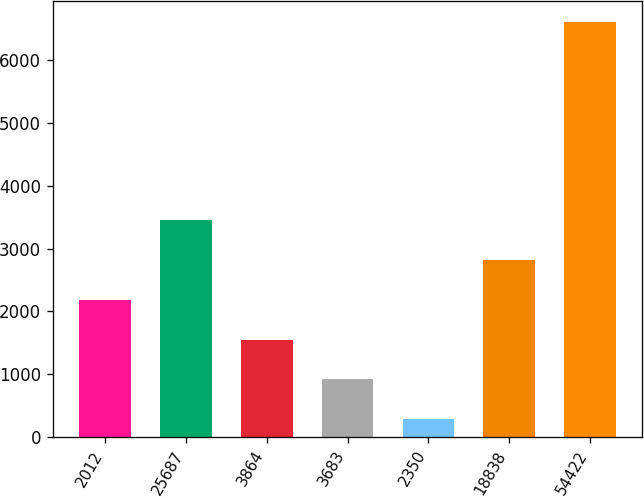Convert chart to OTSL. <chart><loc_0><loc_0><loc_500><loc_500><bar_chart><fcel>2012<fcel>25687<fcel>3864<fcel>3683<fcel>2350<fcel>18838<fcel>54422<nl><fcel>2181.3<fcel>3448.3<fcel>1547.8<fcel>914.3<fcel>280.8<fcel>2814.8<fcel>6615.8<nl></chart> 